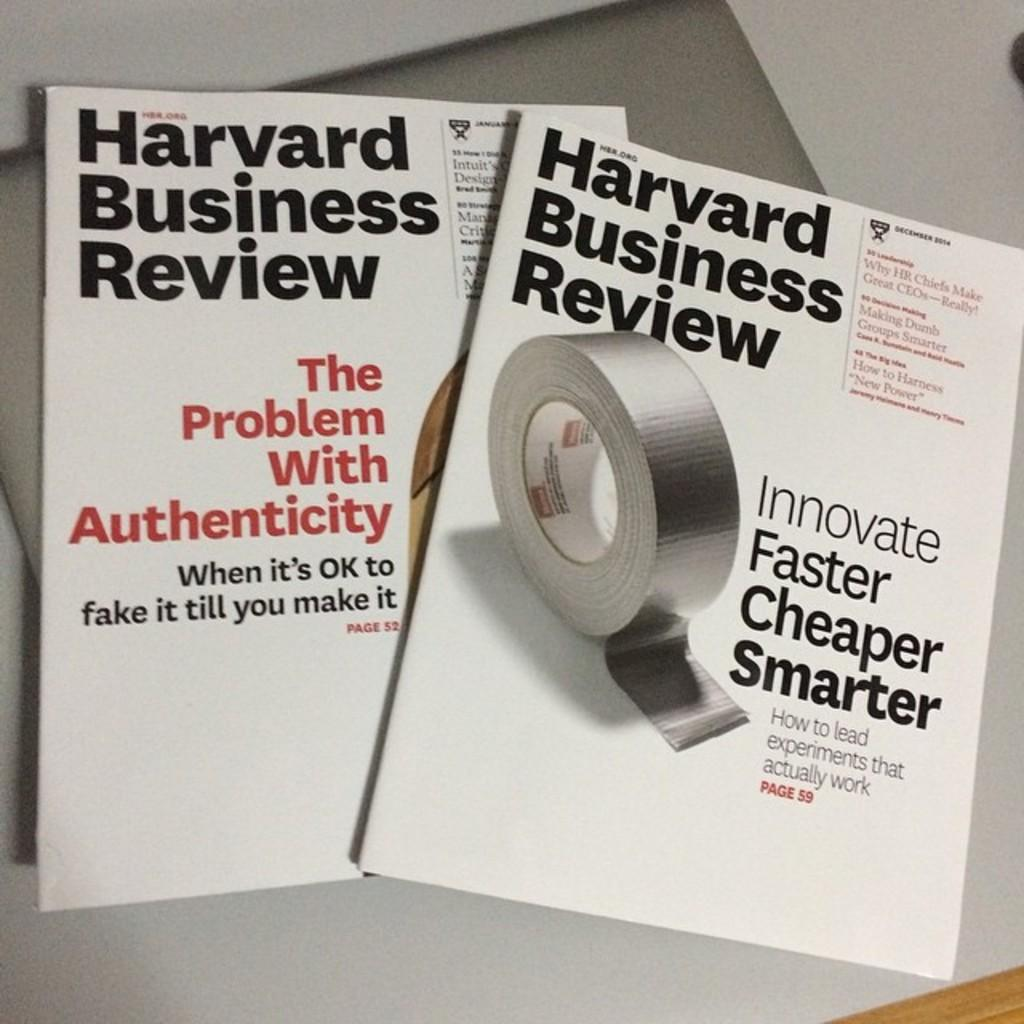Provide a one-sentence caption for the provided image. Two Harvard business review pamphlets sitting on a table. 